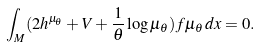<formula> <loc_0><loc_0><loc_500><loc_500>\int _ { M } ( 2 h ^ { \mu _ { \theta } } + V + \frac { 1 } { \theta } \log \mu _ { \theta } ) f \mu _ { \theta } \, d x = 0 .</formula> 